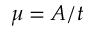Convert formula to latex. <formula><loc_0><loc_0><loc_500><loc_500>\mu = A / t</formula> 